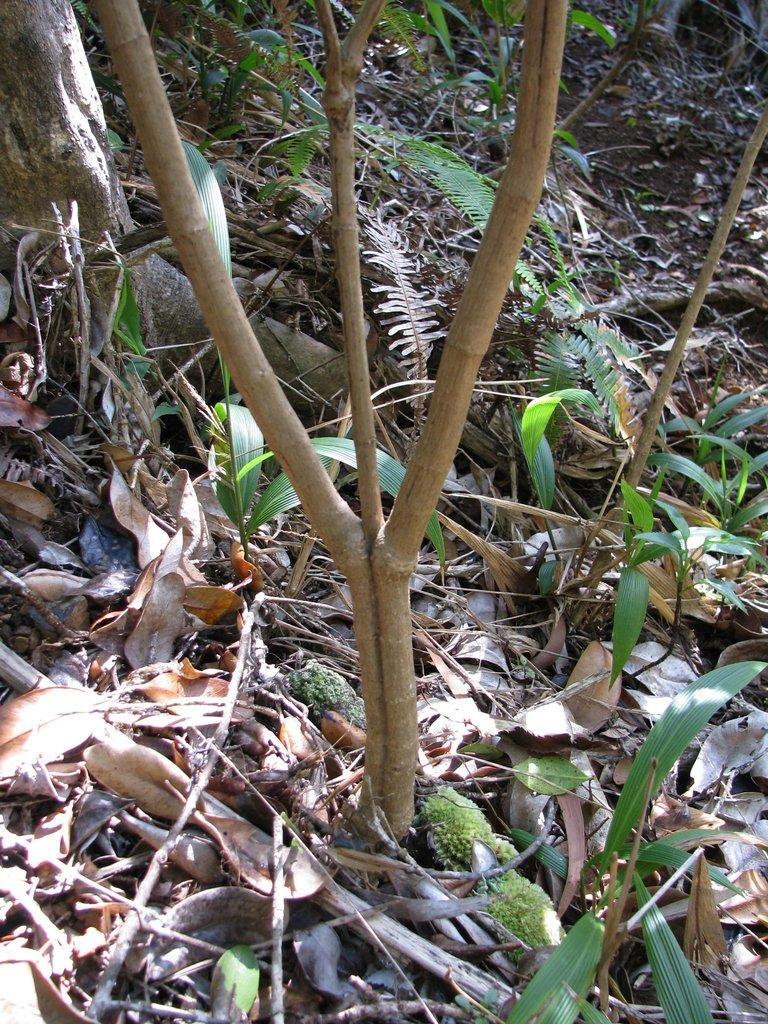Please provide a concise description of this image. In this image we can see trees and plants. On the ground there are dried leaves and sticks. 